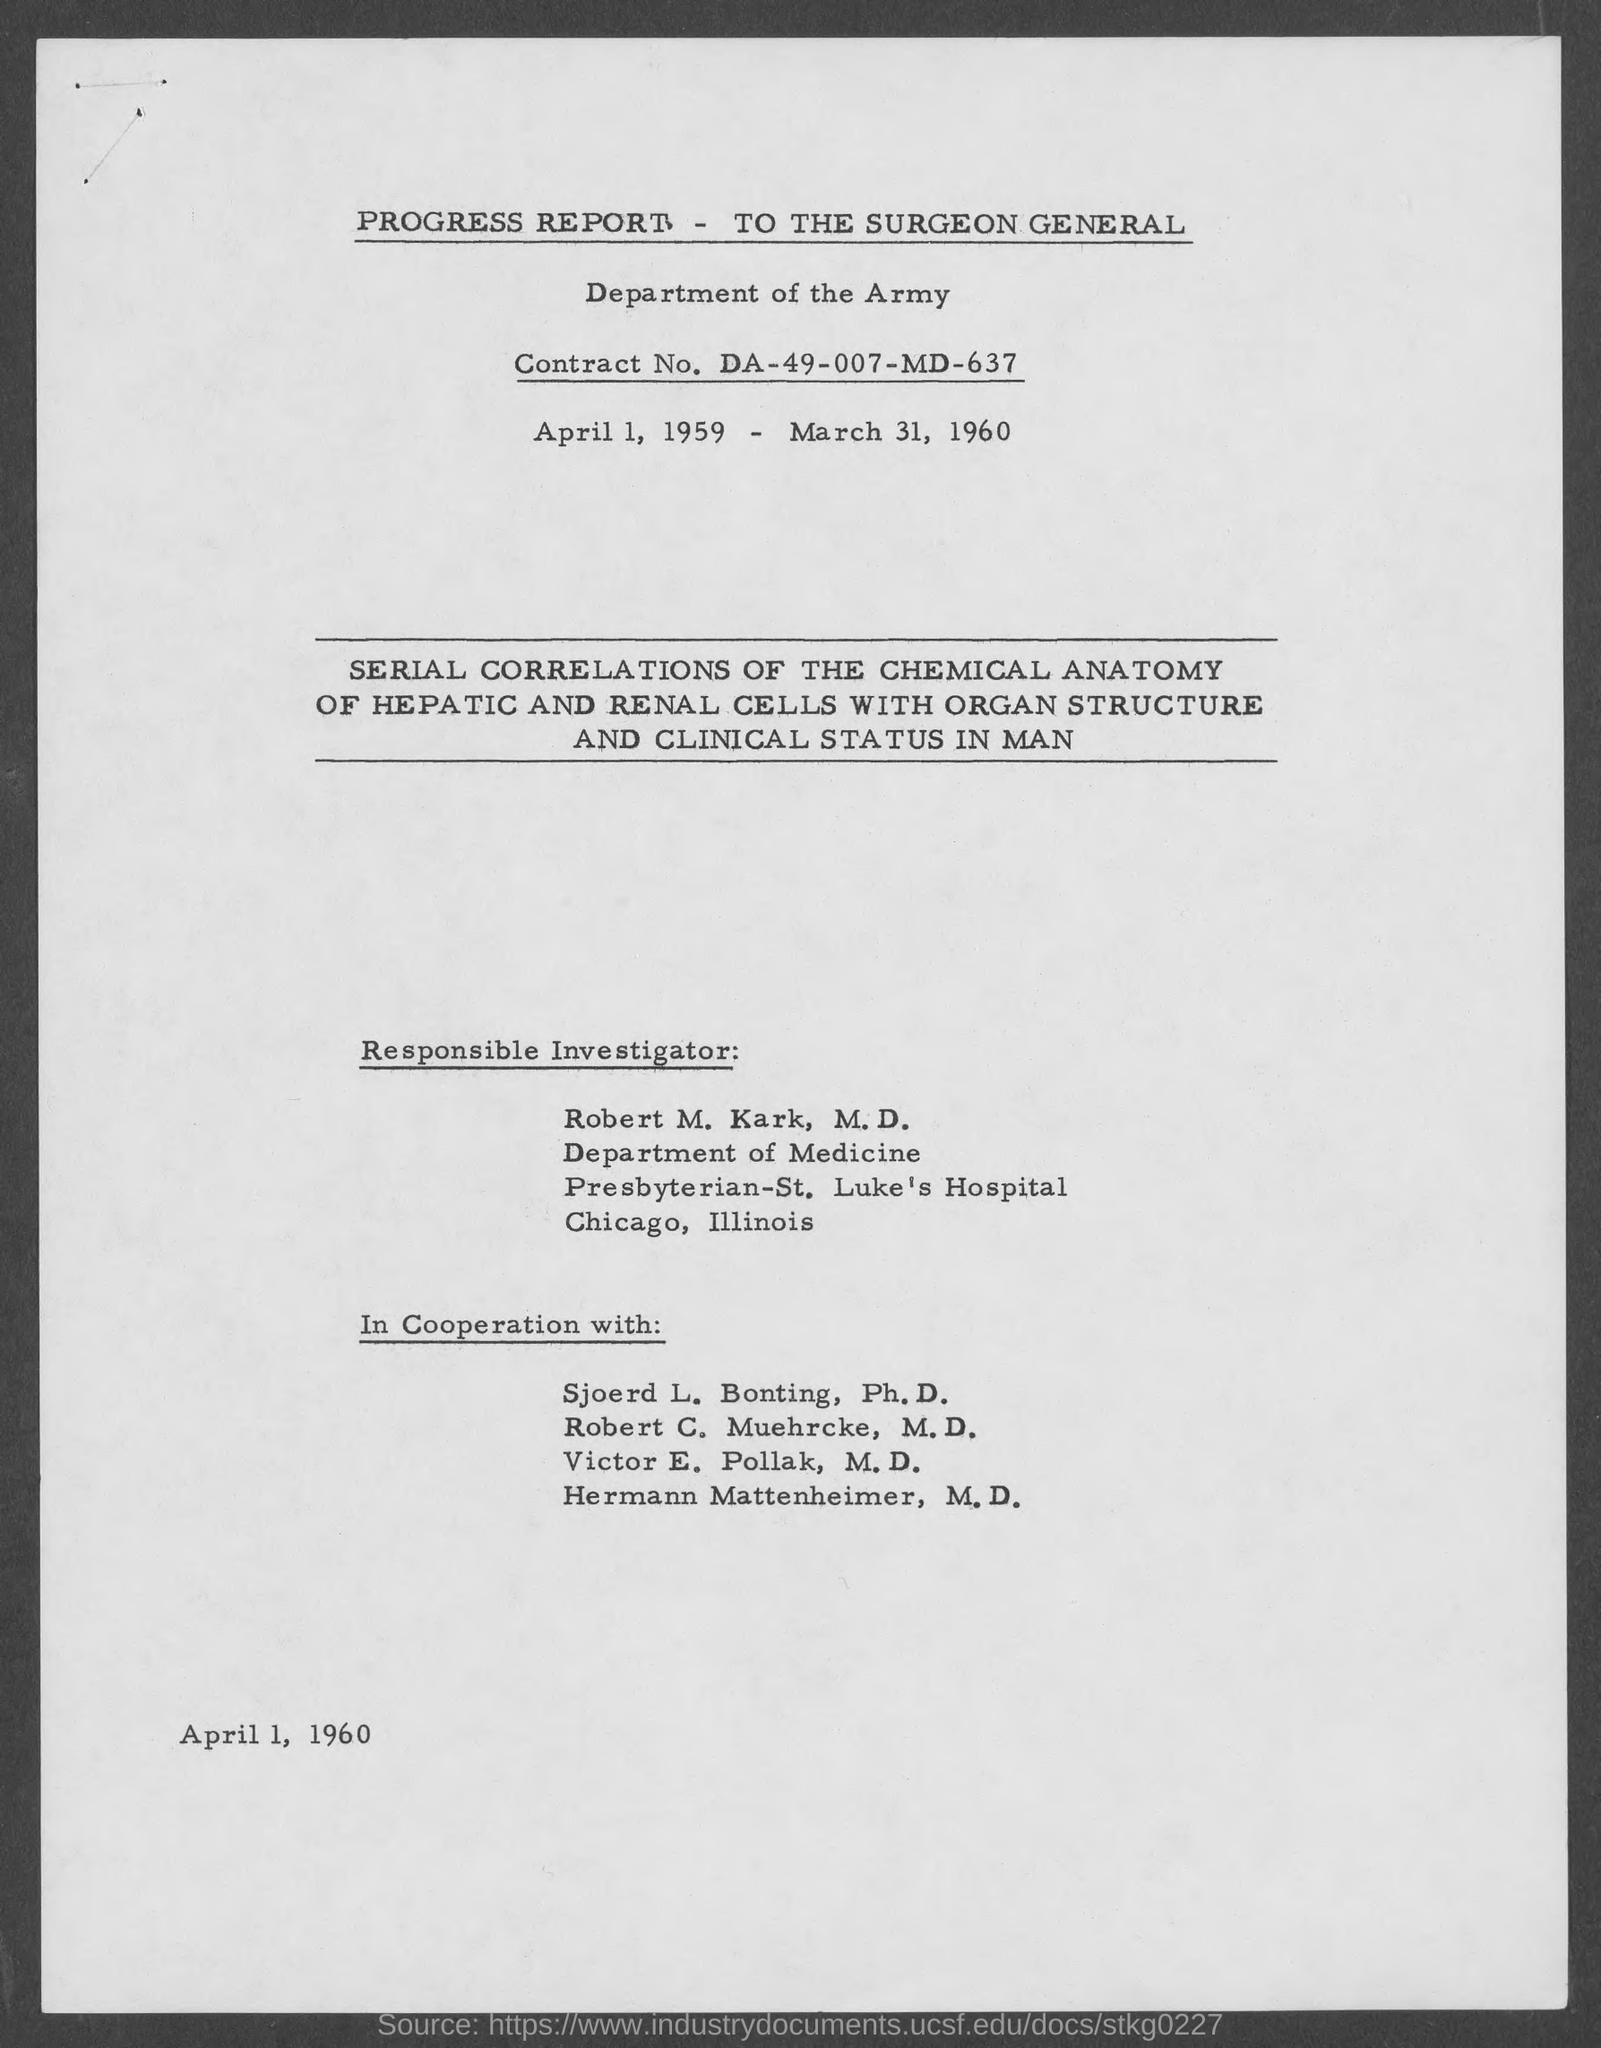What is the contract no.?
Keep it short and to the point. DA-49-007-MD-637. What is the date at bottom of the page?
Offer a very short reply. April 1, 1960. Who is the responsible investigator?
Your answer should be compact. Robert m. kark, m.d. To which department does robert m. kark belong ?
Your answer should be very brief. Department of medicine. 